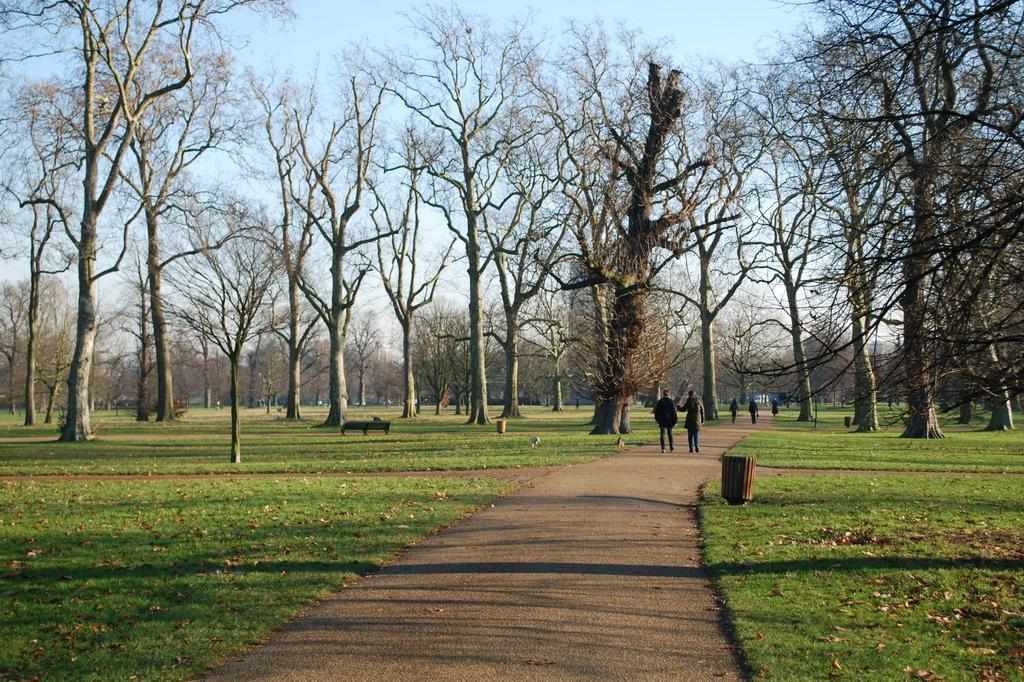Can you describe this image briefly? In this image we can see these people are walking on the road. On the either side of the image we can see grass, trees, bench, trash cans and sky in the background. 